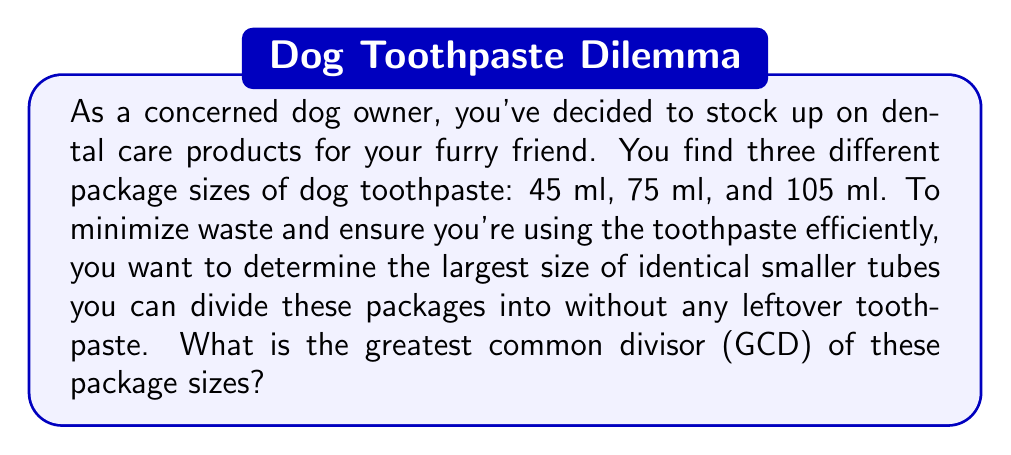What is the answer to this math problem? To find the greatest common divisor (GCD) of 45, 75, and 105, we can use the Euclidean algorithm repeatedly:

1) First, let's arrange the numbers in descending order: 105, 75, 45

2) Apply the Euclidean algorithm to the first two numbers:
   $$105 = 1 \times 75 + 30$$
   $$75 = 2 \times 30 + 15$$
   $$30 = 2 \times 15 + 0$$

   The GCD of 105 and 75 is 15.

3) Now, we need to find the GCD of 15 and 45:
   $$45 = 3 \times 15 + 0$$

Therefore, the GCD of 15 and 45 is 15.

Since 15 is the GCD of all three numbers, it's the largest size of identical smaller tubes that can be created from all three package sizes without any leftover toothpaste.

We can verify this:
$$45 = 3 \times 15$$
$$75 = 5 \times 15$$
$$105 = 7 \times 15$$

This means you can divide the 45 ml package into 3 tubes, the 75 ml package into 5 tubes, and the 105 ml package into 7 tubes, all of 15 ml each.
Answer: The greatest common divisor of 45, 75, and 105 is 15. 